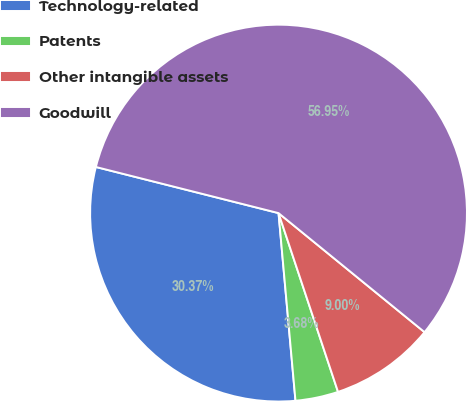Convert chart to OTSL. <chart><loc_0><loc_0><loc_500><loc_500><pie_chart><fcel>Technology-related<fcel>Patents<fcel>Other intangible assets<fcel>Goodwill<nl><fcel>30.37%<fcel>3.68%<fcel>9.0%<fcel>56.95%<nl></chart> 